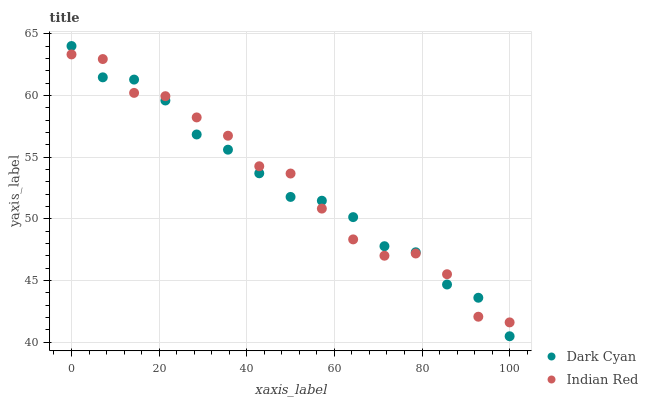Does Dark Cyan have the minimum area under the curve?
Answer yes or no. Yes. Does Indian Red have the maximum area under the curve?
Answer yes or no. Yes. Does Indian Red have the minimum area under the curve?
Answer yes or no. No. Is Dark Cyan the smoothest?
Answer yes or no. Yes. Is Indian Red the roughest?
Answer yes or no. Yes. Is Indian Red the smoothest?
Answer yes or no. No. Does Dark Cyan have the lowest value?
Answer yes or no. Yes. Does Indian Red have the lowest value?
Answer yes or no. No. Does Dark Cyan have the highest value?
Answer yes or no. Yes. Does Indian Red have the highest value?
Answer yes or no. No. Does Indian Red intersect Dark Cyan?
Answer yes or no. Yes. Is Indian Red less than Dark Cyan?
Answer yes or no. No. Is Indian Red greater than Dark Cyan?
Answer yes or no. No. 